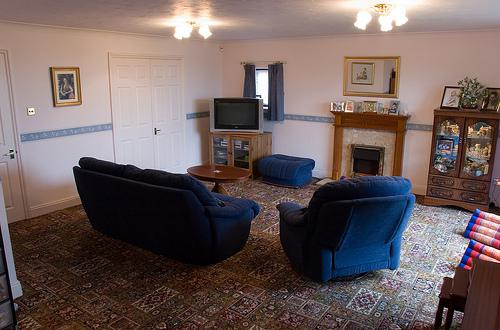Question: what room is this?
Choices:
A. Bathroom.
B. Living room.
C. Bedroom.
D. Garage.
Answer with the letter. Answer: B Question: what is behind the TV?
Choices:
A. Door.
B. Window.
C. Person.
D. Curtain.
Answer with the letter. Answer: B Question: who is standing by the TV?
Choices:
A. No one.
B. A girl.
C. A man.
D. A dog.
Answer with the letter. Answer: A 